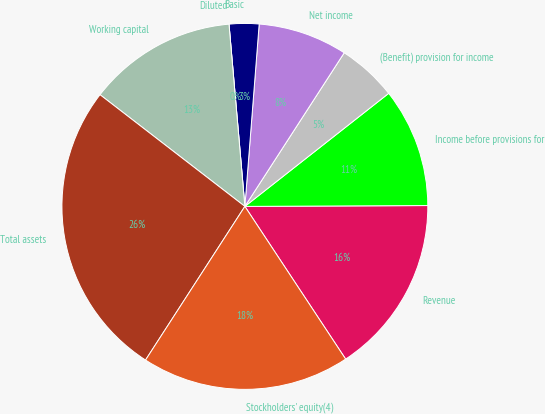Convert chart to OTSL. <chart><loc_0><loc_0><loc_500><loc_500><pie_chart><fcel>Revenue<fcel>Income before provisions for<fcel>(Benefit) provision for income<fcel>Net income<fcel>Basic<fcel>Diluted<fcel>Working capital<fcel>Total assets<fcel>Stockholders' equity(4)<nl><fcel>15.79%<fcel>10.53%<fcel>5.26%<fcel>7.89%<fcel>2.63%<fcel>0.0%<fcel>13.16%<fcel>26.32%<fcel>18.42%<nl></chart> 